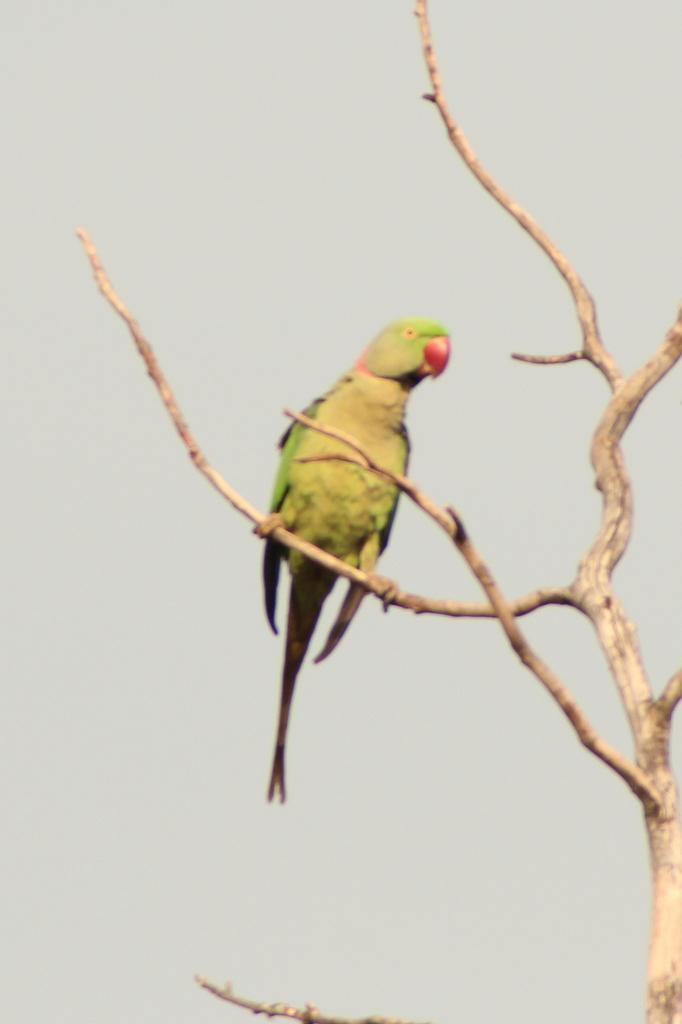What type of animal is in the image? There is a parrot in the image. Where is the parrot located? The parrot is standing on a tree branch. What can be seen in the background of the image? There is sky visible in the background of the image. What is the condition of the sky in the image? There are clouds in the sky. What type of fruit is the parrot holding in the image? There is no fruit present in the image, and the parrot is not holding anything. 